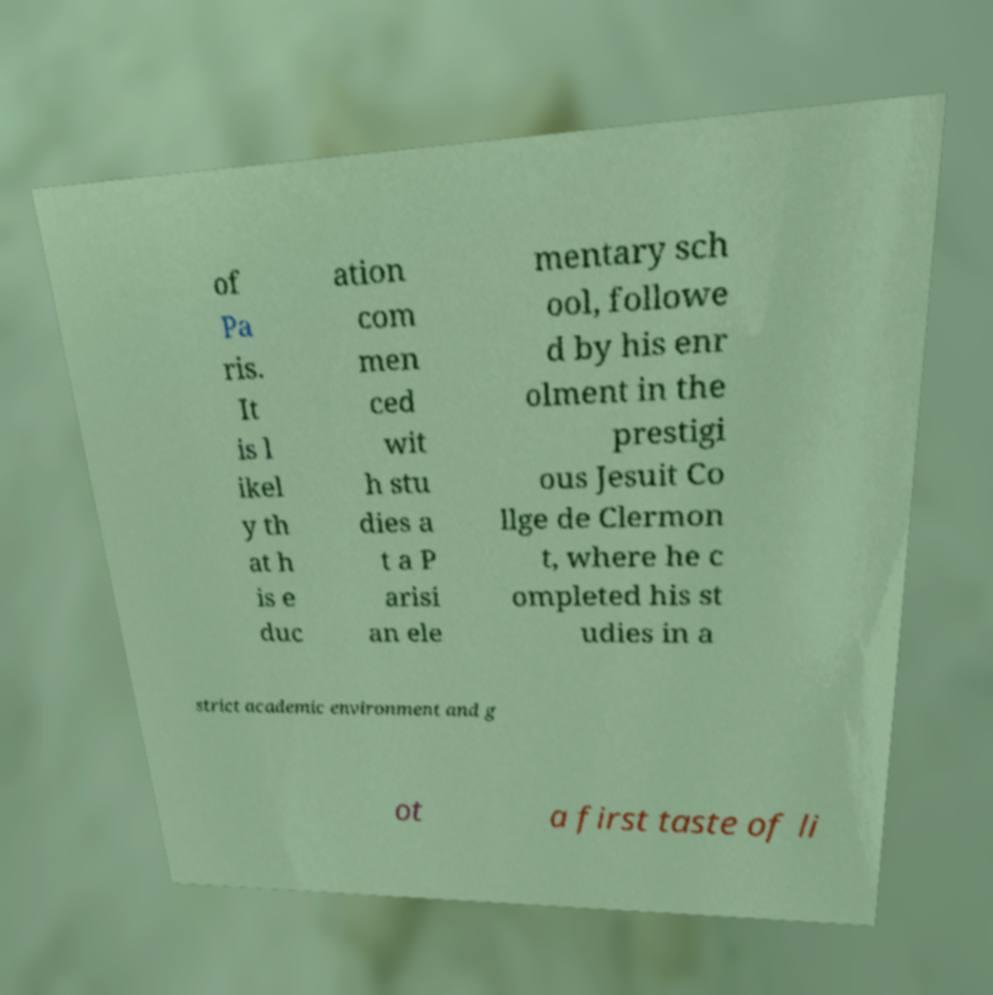Please identify and transcribe the text found in this image. of Pa ris. It is l ikel y th at h is e duc ation com men ced wit h stu dies a t a P arisi an ele mentary sch ool, followe d by his enr olment in the prestigi ous Jesuit Co llge de Clermon t, where he c ompleted his st udies in a strict academic environment and g ot a first taste of li 